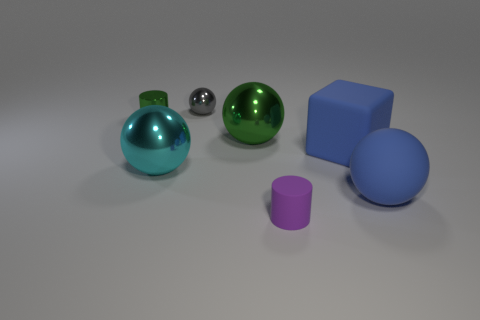There is a blue block; what number of large cyan balls are on the left side of it?
Make the answer very short. 1. What is the size of the ball that is on the right side of the rubber thing behind the ball that is to the right of the tiny matte cylinder?
Offer a very short reply. Large. Is there a tiny object on the right side of the small shiny object that is right of the green metallic thing that is to the left of the tiny gray metal thing?
Offer a terse response. Yes. Are there more tiny metallic objects than tiny rubber objects?
Your response must be concise. Yes. What color is the big ball that is right of the blue rubber cube?
Offer a very short reply. Blue. Are there more balls on the right side of the tiny purple cylinder than red shiny cylinders?
Your response must be concise. Yes. Do the blue cube and the small purple object have the same material?
Provide a succinct answer. Yes. How many other things are there of the same shape as the small green metal thing?
Give a very brief answer. 1. The large metal object that is left of the object behind the tiny green shiny thing that is to the left of the tiny gray ball is what color?
Give a very brief answer. Cyan. Do the tiny object on the left side of the cyan metal sphere and the purple matte object have the same shape?
Your response must be concise. Yes. 